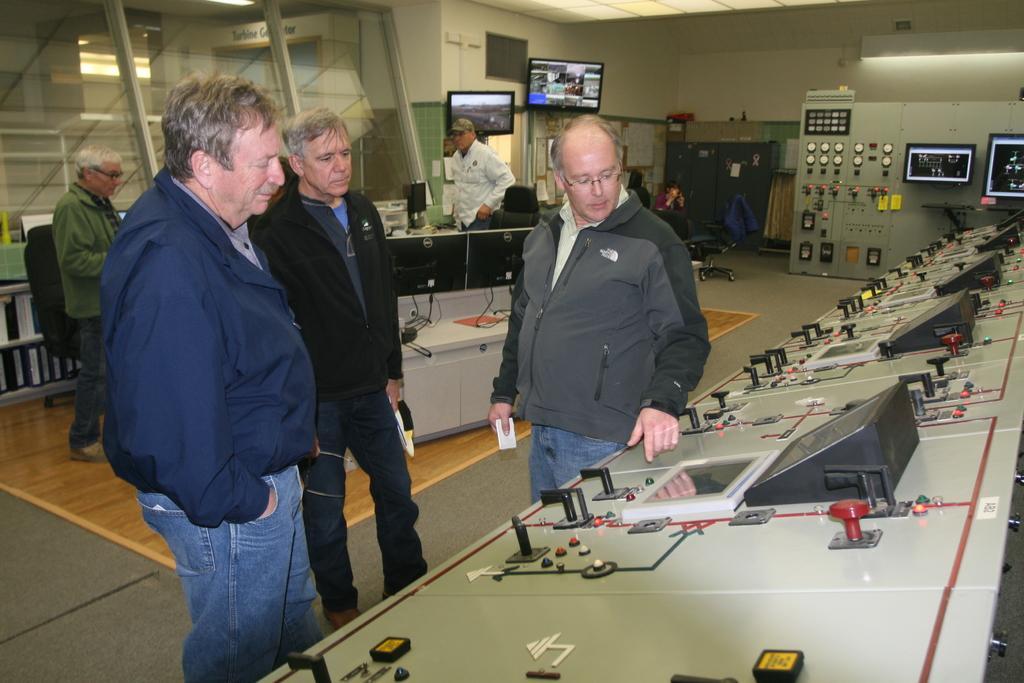In one or two sentences, can you explain what this image depicts? This picture shows the inner view of a laboratory building, one curtain, many machines, for T. V's, one light and some books on the rack. Some objects attached to the wall. There are some chairs, tables and some objects on the tables and chair. Five people are standing and some people are holding some objects. One woman is sitting on a chair. Some objects are on the surface. 